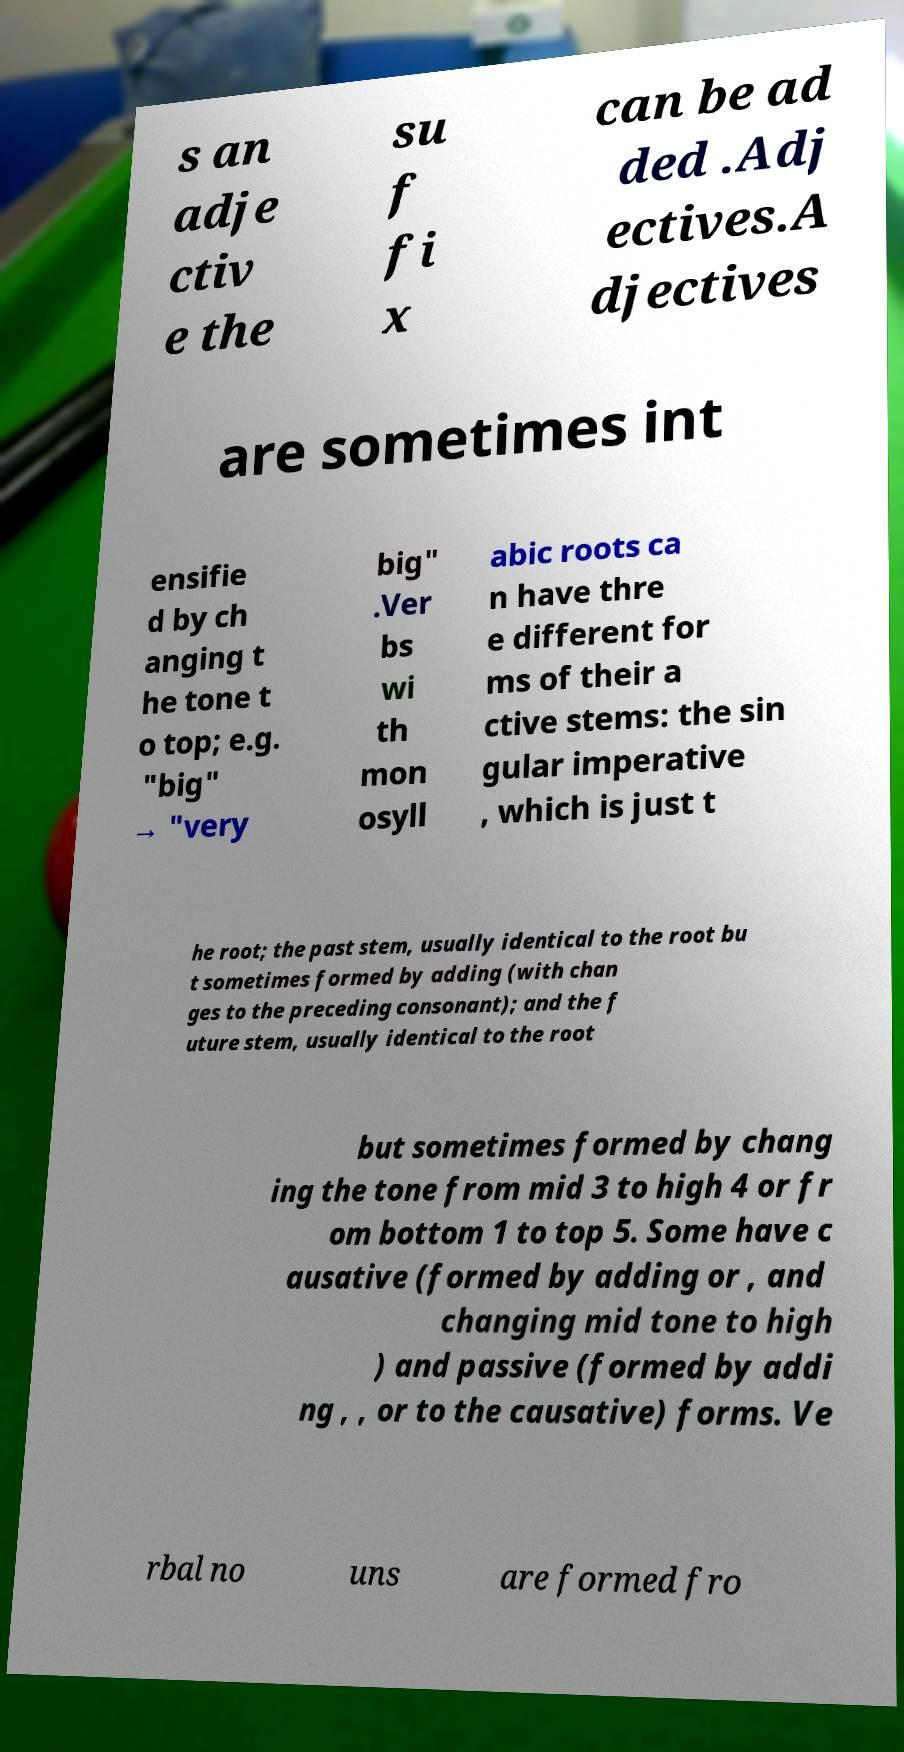Please identify and transcribe the text found in this image. s an adje ctiv e the su f fi x can be ad ded .Adj ectives.A djectives are sometimes int ensifie d by ch anging t he tone t o top; e.g. "big" → "very big" .Ver bs wi th mon osyll abic roots ca n have thre e different for ms of their a ctive stems: the sin gular imperative , which is just t he root; the past stem, usually identical to the root bu t sometimes formed by adding (with chan ges to the preceding consonant); and the f uture stem, usually identical to the root but sometimes formed by chang ing the tone from mid 3 to high 4 or fr om bottom 1 to top 5. Some have c ausative (formed by adding or , and changing mid tone to high ) and passive (formed by addi ng , , or to the causative) forms. Ve rbal no uns are formed fro 